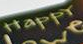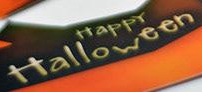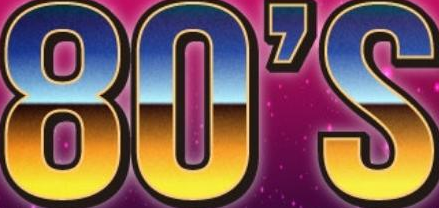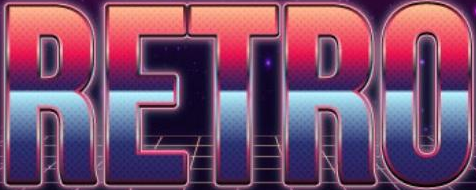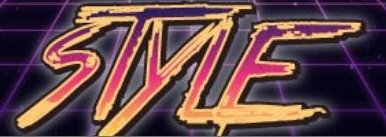What words are shown in these images in order, separated by a semicolon? HappY; Halloween; 80'S; RETRO; STYLE 